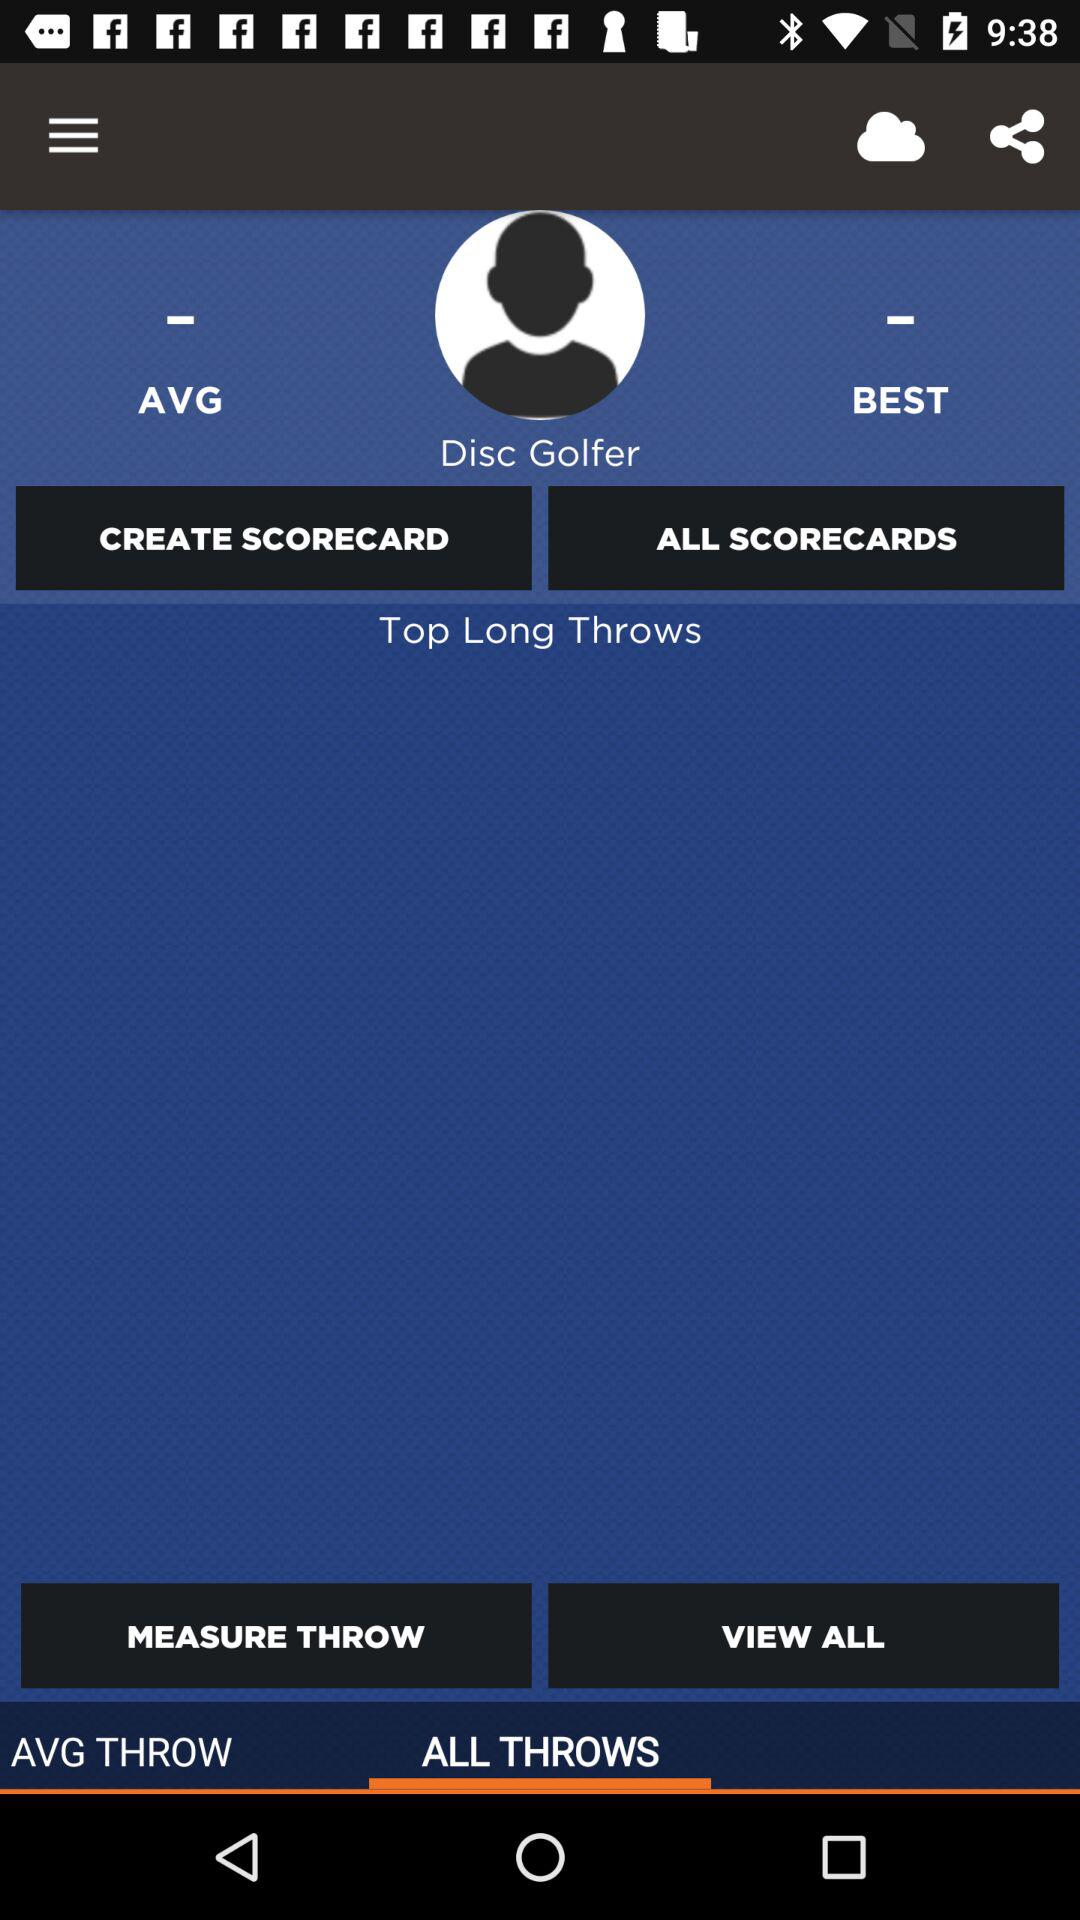What is the user name? The user name is Disc Golfer. 